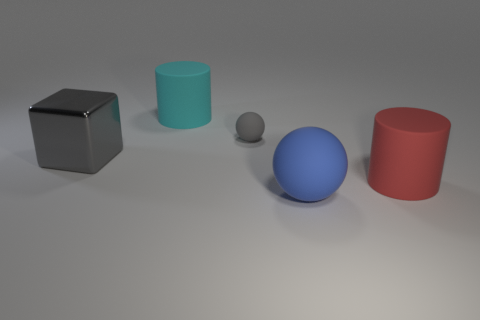Add 3 gray metallic objects. How many objects exist? 8 Subtract 1 red cylinders. How many objects are left? 4 Subtract all cylinders. How many objects are left? 3 Subtract all cyan cylinders. Subtract all purple balls. How many cylinders are left? 1 Subtract all red cylinders. How many green cubes are left? 0 Subtract all gray rubber things. Subtract all big red matte cylinders. How many objects are left? 3 Add 1 metal objects. How many metal objects are left? 2 Add 3 large rubber cylinders. How many large rubber cylinders exist? 5 